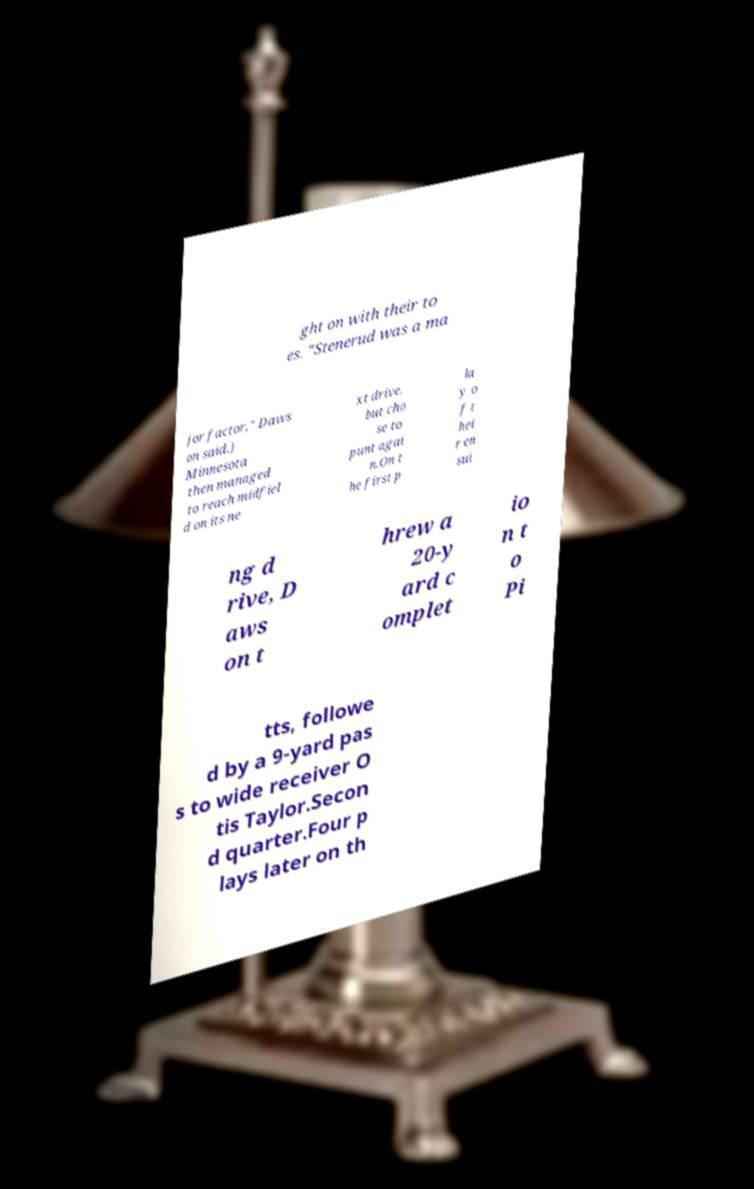There's text embedded in this image that I need extracted. Can you transcribe it verbatim? ght on with their to es. "Stenerud was a ma jor factor," Daws on said.) Minnesota then managed to reach midfiel d on its ne xt drive, but cho se to punt agai n.On t he first p la y o f t hei r en sui ng d rive, D aws on t hrew a 20-y ard c omplet io n t o Pi tts, followe d by a 9-yard pas s to wide receiver O tis Taylor.Secon d quarter.Four p lays later on th 